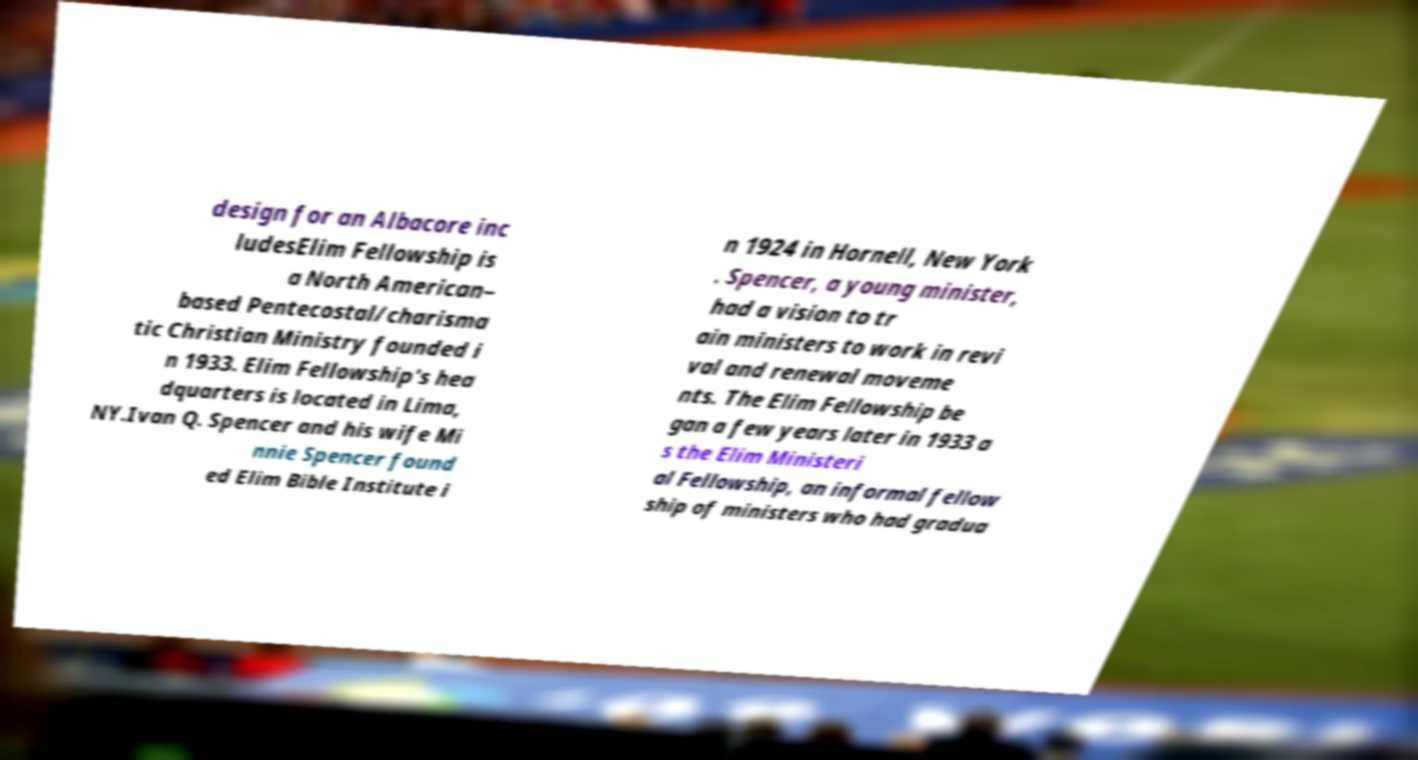Can you accurately transcribe the text from the provided image for me? design for an Albacore inc ludesElim Fellowship is a North American– based Pentecostal/charisma tic Christian Ministry founded i n 1933. Elim Fellowship's hea dquarters is located in Lima, NY.Ivan Q. Spencer and his wife Mi nnie Spencer found ed Elim Bible Institute i n 1924 in Hornell, New York . Spencer, a young minister, had a vision to tr ain ministers to work in revi val and renewal moveme nts. The Elim Fellowship be gan a few years later in 1933 a s the Elim Ministeri al Fellowship, an informal fellow ship of ministers who had gradua 